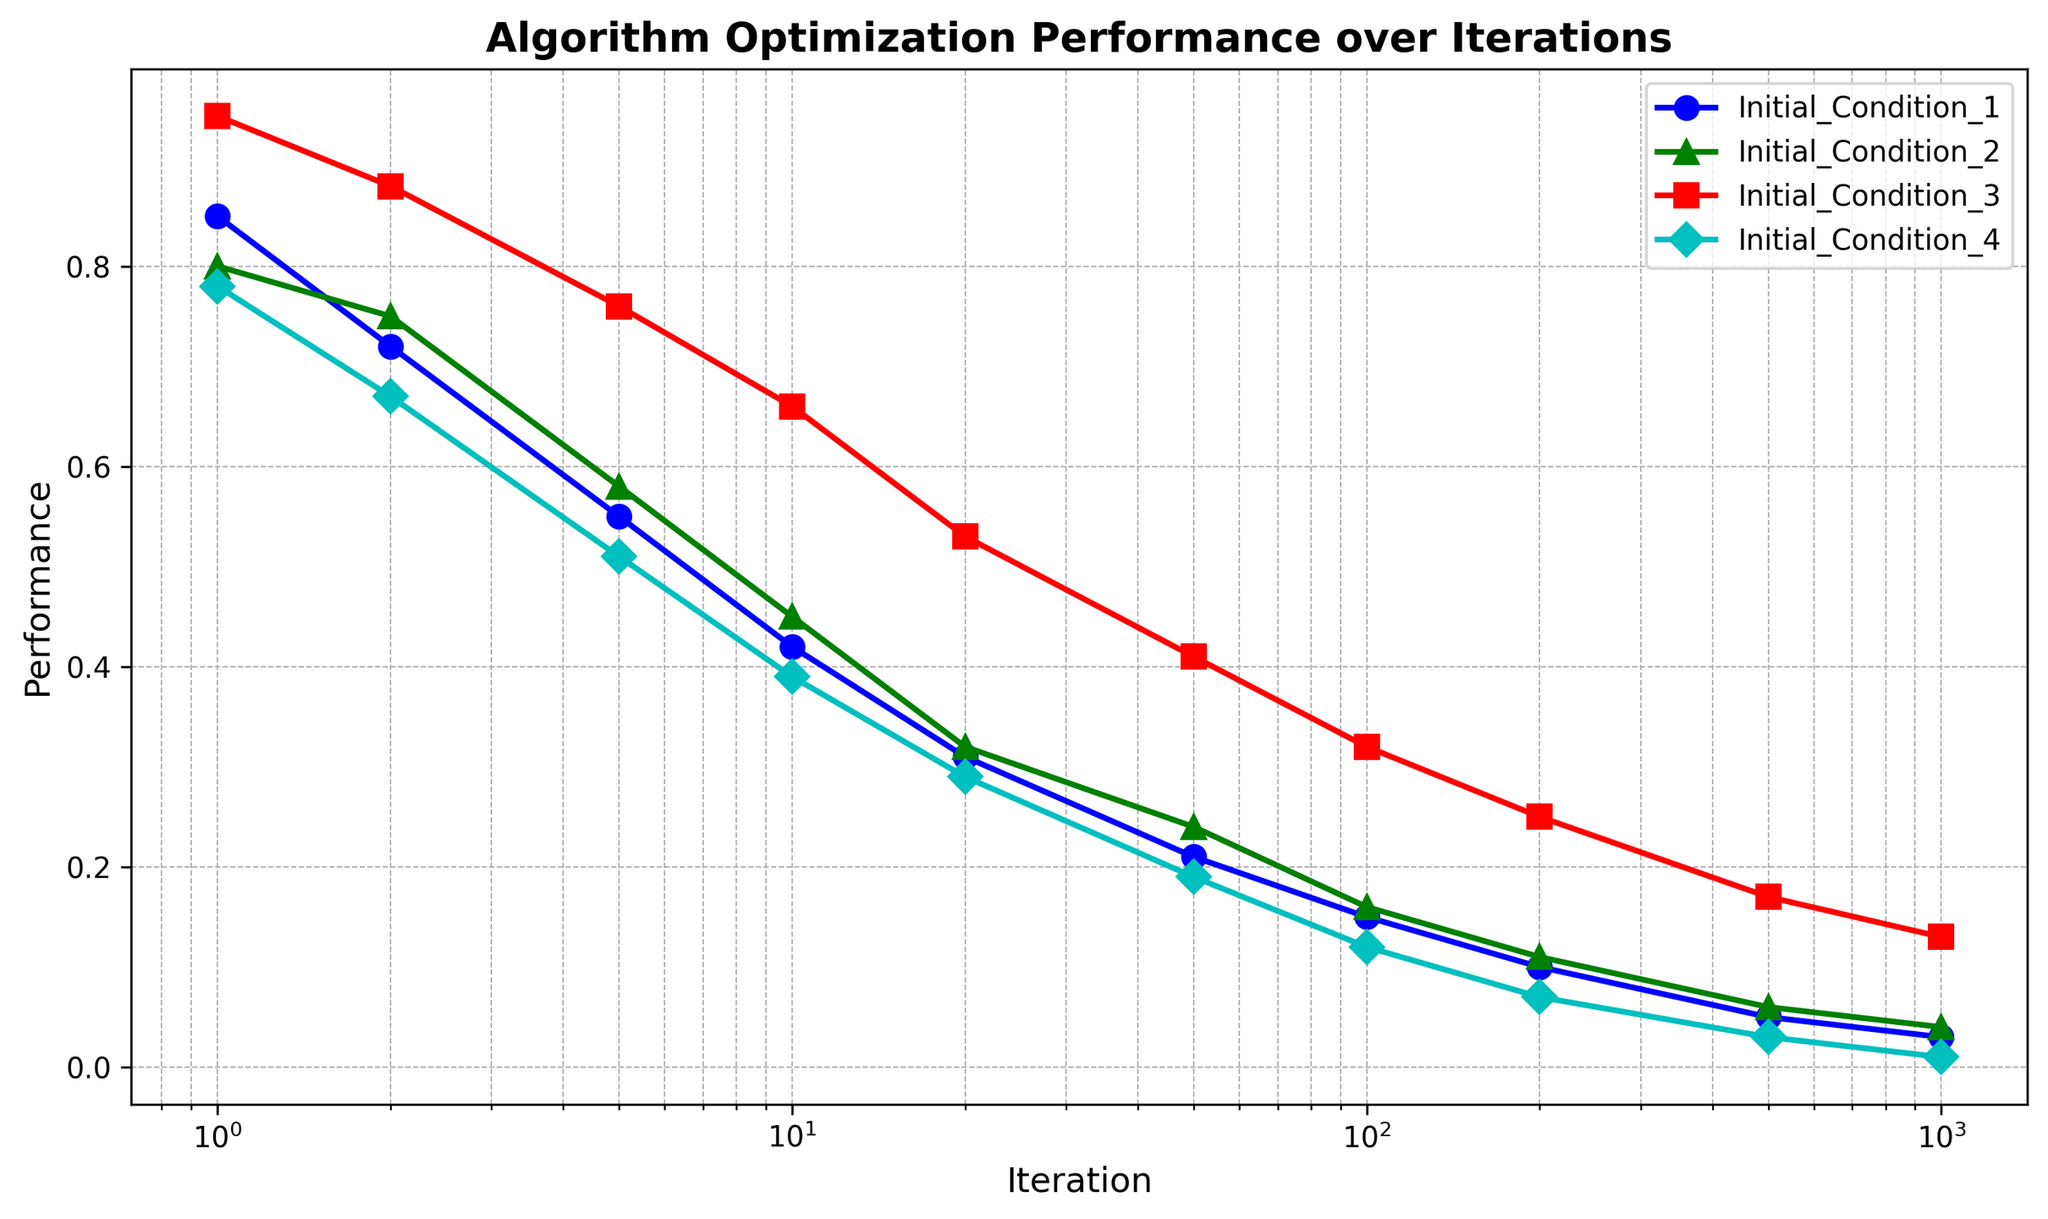Which initial condition performed the best at the start? The initial performances can be seen at iteration 1. By looking at the y-values for iteration 1, Initial Condition 3 has the highest value.
Answer: Initial Condition 3 How does the performance of Initial Condition 4 compare to Initial Condition 2 at iteration 100? At iteration 100, we can compare the y-values for Initial Condition 4 and Initial Condition 2. The performance of Initial Condition 4 is lower than that of Initial Condition 2, specifically 0.12 vs. 0.16.
Answer: Initial Condition 4 is worse What is the difference in performance between the best and worst initial conditions at iteration 500? At iteration 500, Initial Condition 3 has a performance of 0.17 and Initial Condition 4 has a performance of 0.03. The difference is 0.17 - 0.03.
Answer: 0.14 Which initial condition had the most consistent decline in performance over the iterations? By observing the slopes of the lines, Initial Condition 2 has a smoother and more consistent decline compared to the other conditions whose performance fluctuates more noticeably.
Answer: Initial Condition 2 At iteration 10, what are the ranks of performances from best to worst among all initial conditions? At iteration 10, the performance values are: Initial Condition 1 = 0.42, Initial Condition 2 = 0.45, Initial Condition 3 = 0.66, Initial Condition 4 = 0.39. Arranging these from best to worst: Initial Condition 3, Initial Condition 2, Initial Condition 1, Initial Condition 4.
Answer: 3 > 2 > 1 > 4 What is the average performance of Initial Condition 1 over all iterations? Add performance values for Initial Condition 1 across each iteration and divide by the number of iterations: (0.85 + 0.72 + 0.55 + 0.42 + 0.31 + 0.21 + 0.15 + 0.10 + 0.05 + 0.03)/10.
Answer: 0.339 Which initial condition improves slower at earlier iterations but catches up significantly after iteration 50? Initial Condition 3 starts slower comparatively but shows substantial improvement and outperforms other initial conditions significantly starting around iteration 50.
Answer: Initial Condition 3 What is the relative performance of Initial Condition 1 compared to Initial Condition 3 at iteration 200? At iteration 200, Initial Condition 1's performance is 0.10, and Initial Condition 3's performance is 0.25. Thus, Initial Condition 1's performance is 0.10/0.25 of Initial Condition 3's performance.
Answer: 0.40 Which initial condition shows the steepest decline in performance between iterations 1 and 2? By comparing the performance drop from iteration 1 to iteration 2 for each initial condition, Initial Condition 3 shows the most significant drop (0.95 to 0.88).
Answer: Initial Condition 3 